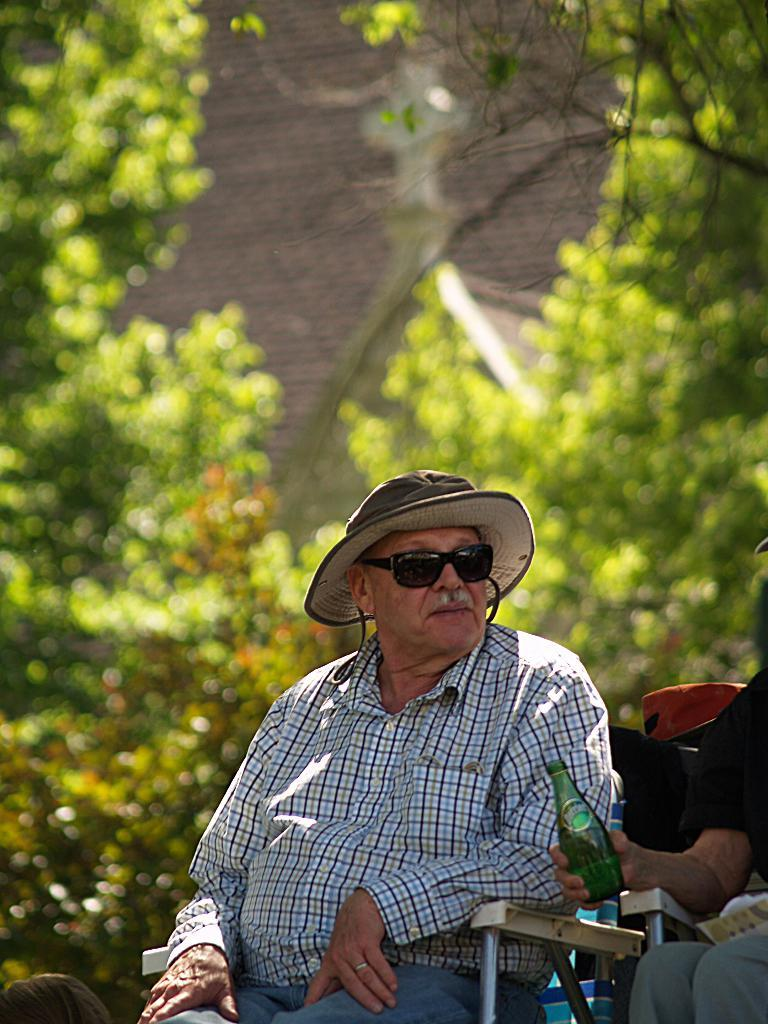What is the position of the first man in the image? The first man is sitting on a chair in the image. Who is sitting beside the first man? There is another man sitting beside the first man. What is the second man holding in the image? The second man is holding a bottle in the image. What can be seen in the background of the image? A: There are many trees visible in the image. Reasoning: Let'g: Let's think step by step in order to produce the conversation. We start by identifying the main subjects in the image, which are the two men sitting on chairs. Then, we describe their positions and actions, noting that the second man is holding a bottle. Finally, we mention the background of the image, which includes many trees. Each question is designed to elicit a specific detail about the image that is known from the provided facts. Absurd Question/Answer: What type of government is being discussed by the two men in the image? There is no indication in the image that the two men are discussing any type of government. 